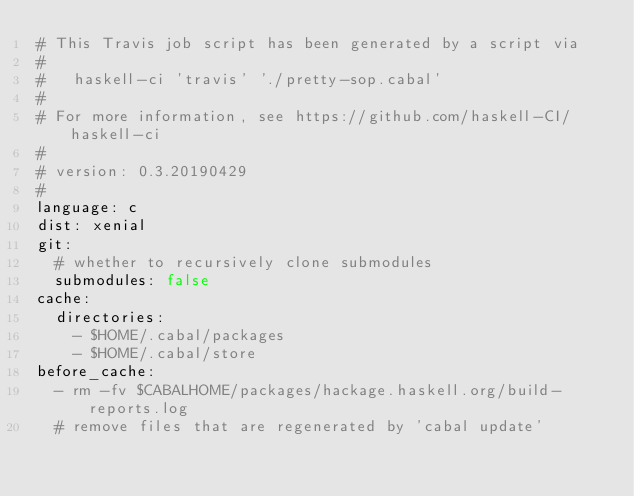Convert code to text. <code><loc_0><loc_0><loc_500><loc_500><_YAML_># This Travis job script has been generated by a script via
#
#   haskell-ci 'travis' './pretty-sop.cabal'
#
# For more information, see https://github.com/haskell-CI/haskell-ci
#
# version: 0.3.20190429
#
language: c
dist: xenial
git:
  # whether to recursively clone submodules
  submodules: false
cache:
  directories:
    - $HOME/.cabal/packages
    - $HOME/.cabal/store
before_cache:
  - rm -fv $CABALHOME/packages/hackage.haskell.org/build-reports.log
  # remove files that are regenerated by 'cabal update'</code> 